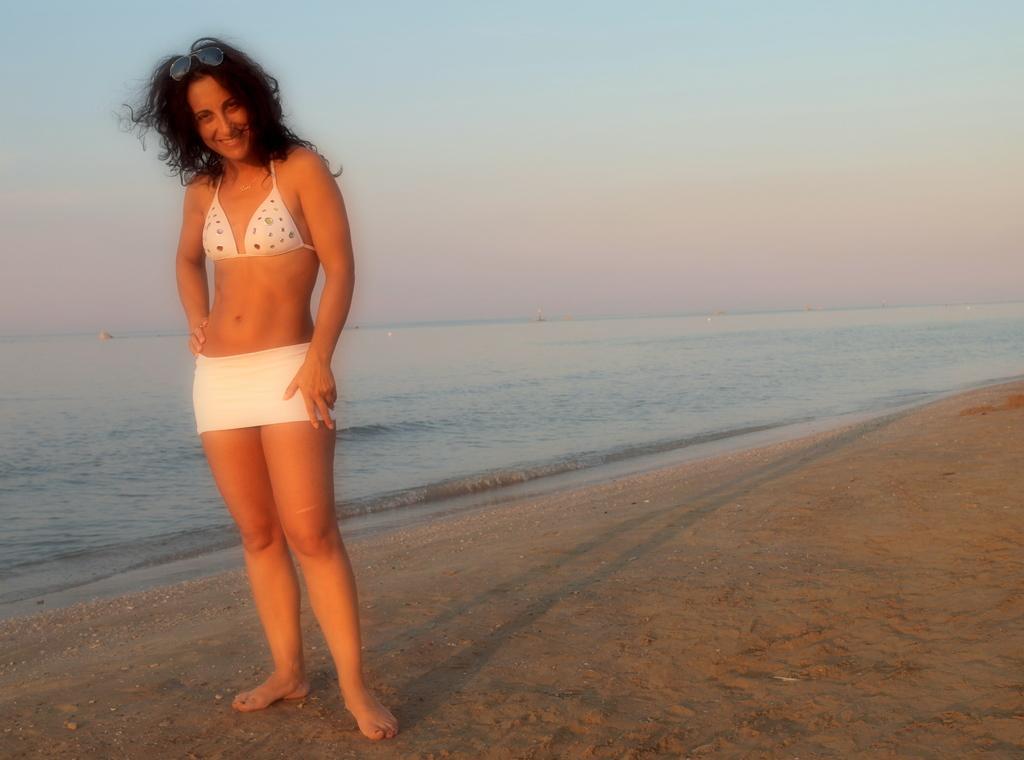In one or two sentences, can you explain what this image depicts? In this image there is a woman standing and smiling, there is water, and in the background there is sky. 